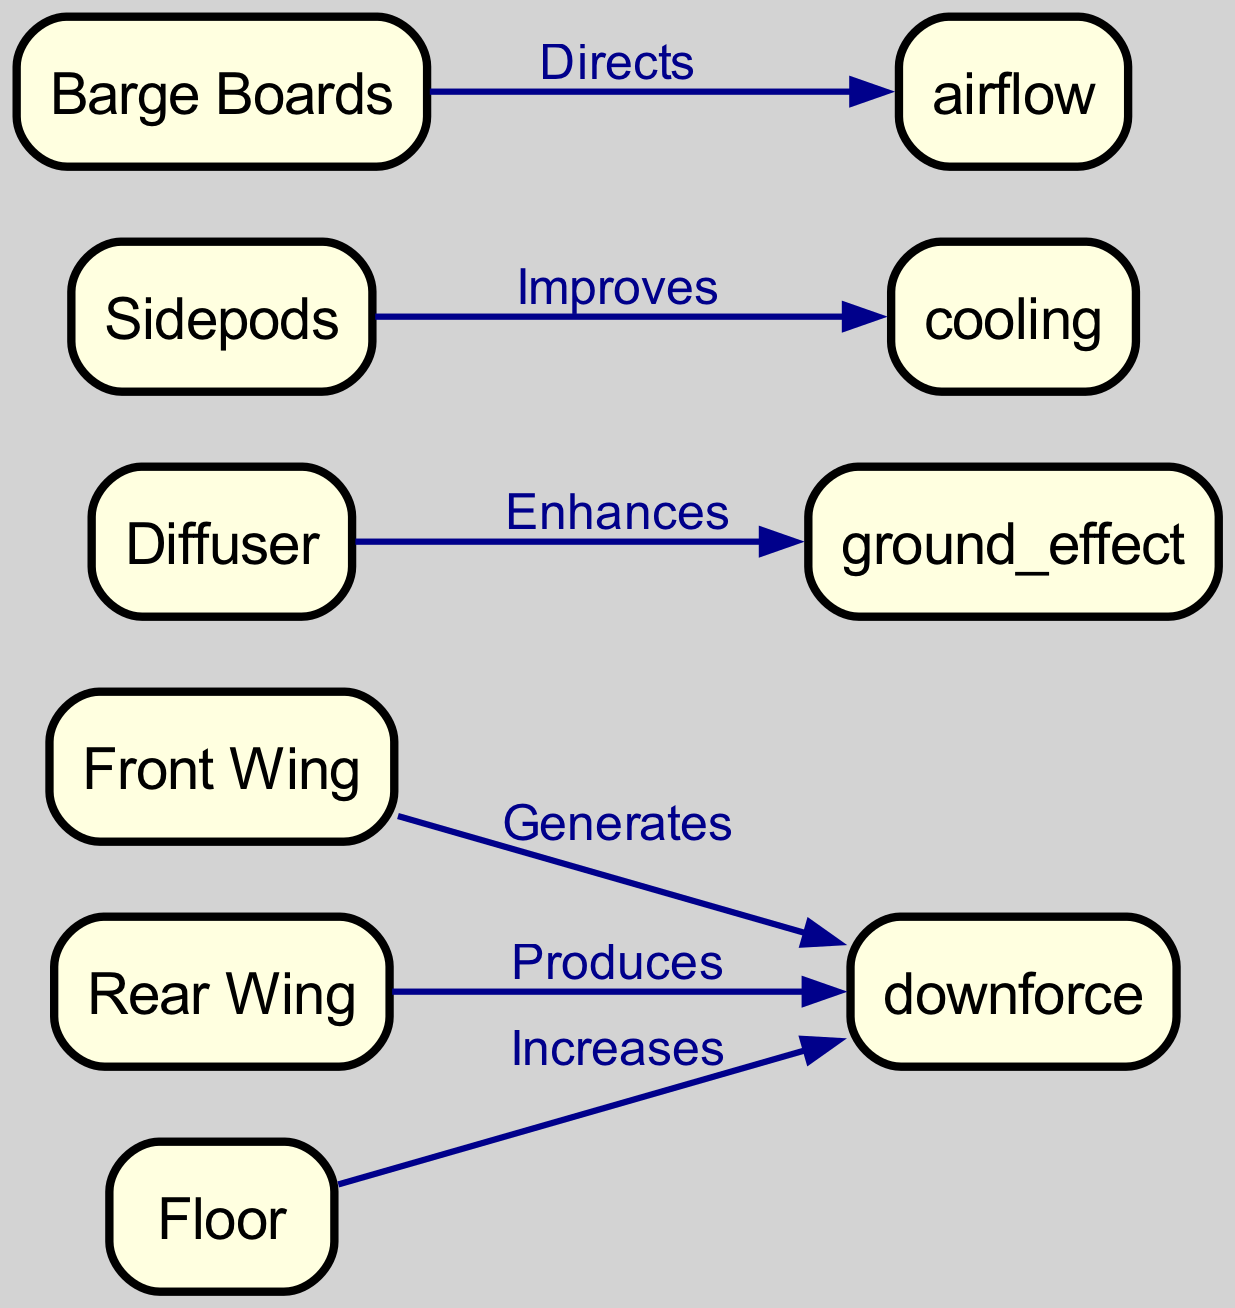What are the main aerodynamic components of an F1 car? The diagram lists six aerodynamic components: front wing, rear wing, diffuser, sidepods, barge boards, and floor. These are the nodes depicted in the diagram itself.
Answer: Front wing, rear wing, diffuser, sidepods, barge boards, floor How many edges are present in the diagram? The diagram contains five edges that illustrate the relationships between the aerodynamic components and their effects. Each component generates, produces, enhances, improves, or directs specific aerodynamic effects.
Answer: Five What effect does the front wing generate? According to the diagram, the front wing generates downforce, as indicated by the edge labeled "Generates" connecting it to the downforce node.
Answer: Downforce Which component improves cooling? The sidepods are shown in the diagram to improve cooling, with an edge labeled "Improves" connecting them to the cooling node.
Answer: Sidepods What does the diffuser enhance? The diffuser enhances ground effect, as depicted by the edge labeled "Enhances" that connects the diffuser to the ground effect node.
Answer: Ground effect How do the barge boards affect airflow? The diagram indicates that the barge boards direct airflow, with an edge labeled "Directs" leading to the airflow node.
Answer: Airflow Which aerodynamic component is responsible for increasing downforce besides the front wing? The diagram specifies that the floor also increases downforce, as shown by the edge labeled "Increases" that links the floor to the downforce node.
Answer: Floor What is the relationship between the rear wing and downforce? The rear wing produces downforce, indicated by the edge labeled "Produces" connecting it to the downforce node, showing its contribution to downforce generation.
Answer: Produces What is the main effect of the floor on performance? The floor increases downforce, as indicated by the edge labeled "Increases" leading to the downforce node in the diagram.
Answer: Increases downforce 